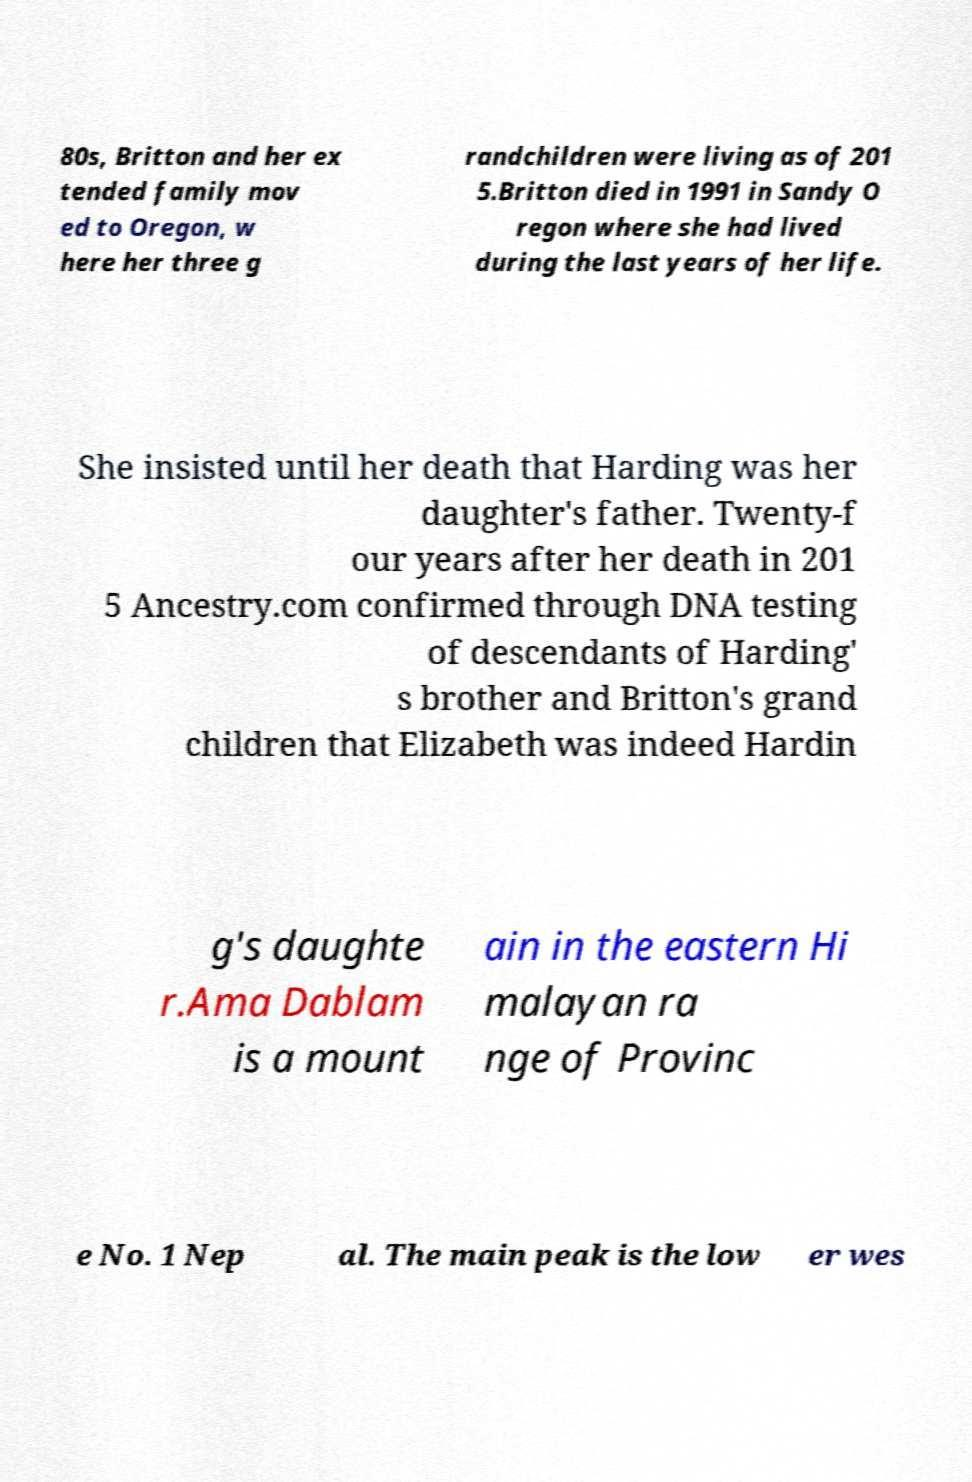Please identify and transcribe the text found in this image. 80s, Britton and her ex tended family mov ed to Oregon, w here her three g randchildren were living as of 201 5.Britton died in 1991 in Sandy O regon where she had lived during the last years of her life. She insisted until her death that Harding was her daughter's father. Twenty-f our years after her death in 201 5 Ancestry.com confirmed through DNA testing of descendants of Harding' s brother and Britton's grand children that Elizabeth was indeed Hardin g's daughte r.Ama Dablam is a mount ain in the eastern Hi malayan ra nge of Provinc e No. 1 Nep al. The main peak is the low er wes 